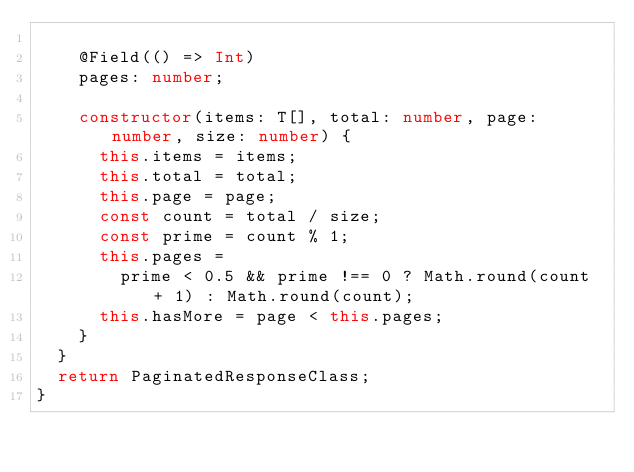<code> <loc_0><loc_0><loc_500><loc_500><_TypeScript_>
    @Field(() => Int)
    pages: number;

    constructor(items: T[], total: number, page: number, size: number) {
      this.items = items;
      this.total = total;
      this.page = page;
      const count = total / size;
      const prime = count % 1;
      this.pages =
        prime < 0.5 && prime !== 0 ? Math.round(count + 1) : Math.round(count);
      this.hasMore = page < this.pages;
    }
  }
  return PaginatedResponseClass;
}
</code> 